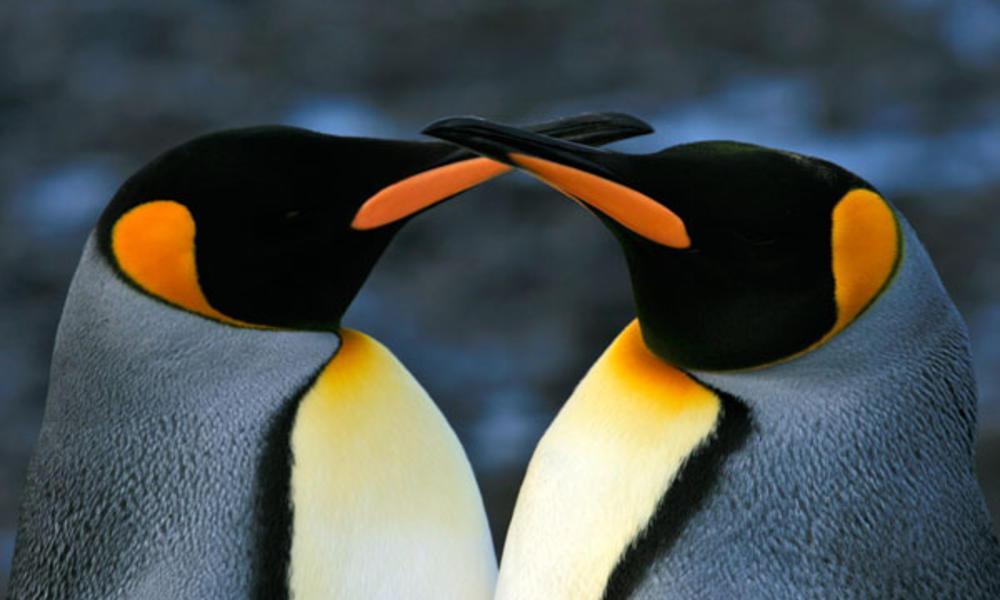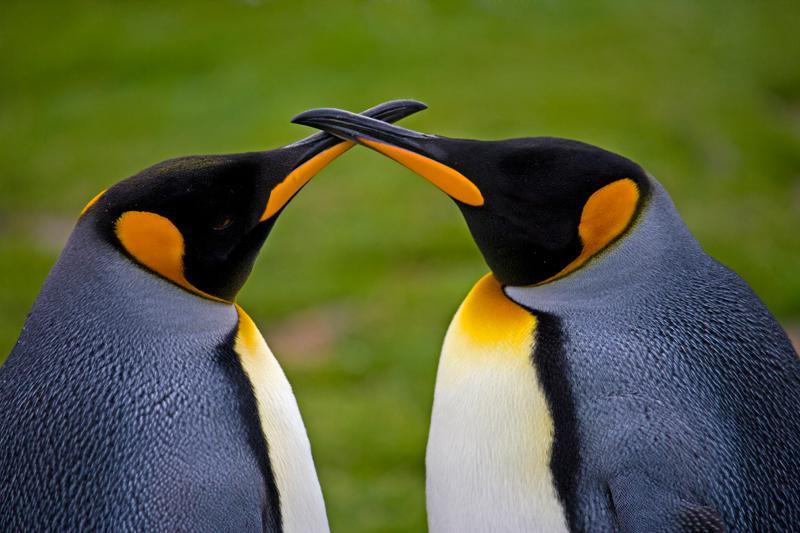The first image is the image on the left, the second image is the image on the right. Examine the images to the left and right. Is the description "There are no more than 4 penguins." accurate? Answer yes or no. Yes. The first image is the image on the left, the second image is the image on the right. Given the left and right images, does the statement "At least one image contains only two penguins facing each other." hold true? Answer yes or no. Yes. 